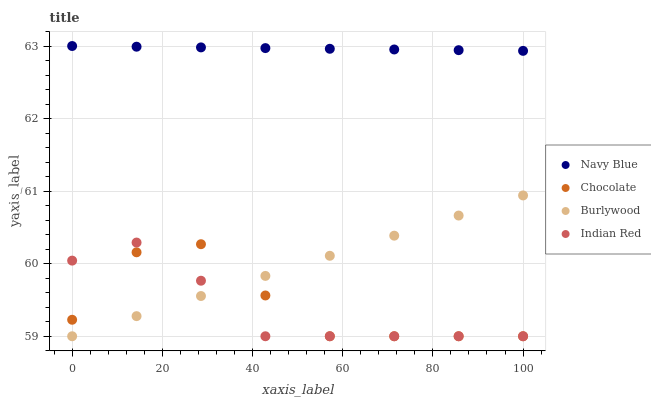Does Indian Red have the minimum area under the curve?
Answer yes or no. Yes. Does Navy Blue have the maximum area under the curve?
Answer yes or no. Yes. Does Navy Blue have the minimum area under the curve?
Answer yes or no. No. Does Indian Red have the maximum area under the curve?
Answer yes or no. No. Is Navy Blue the smoothest?
Answer yes or no. Yes. Is Chocolate the roughest?
Answer yes or no. Yes. Is Indian Red the smoothest?
Answer yes or no. No. Is Indian Red the roughest?
Answer yes or no. No. Does Burlywood have the lowest value?
Answer yes or no. Yes. Does Navy Blue have the lowest value?
Answer yes or no. No. Does Navy Blue have the highest value?
Answer yes or no. Yes. Does Indian Red have the highest value?
Answer yes or no. No. Is Indian Red less than Navy Blue?
Answer yes or no. Yes. Is Navy Blue greater than Burlywood?
Answer yes or no. Yes. Does Burlywood intersect Chocolate?
Answer yes or no. Yes. Is Burlywood less than Chocolate?
Answer yes or no. No. Is Burlywood greater than Chocolate?
Answer yes or no. No. Does Indian Red intersect Navy Blue?
Answer yes or no. No. 